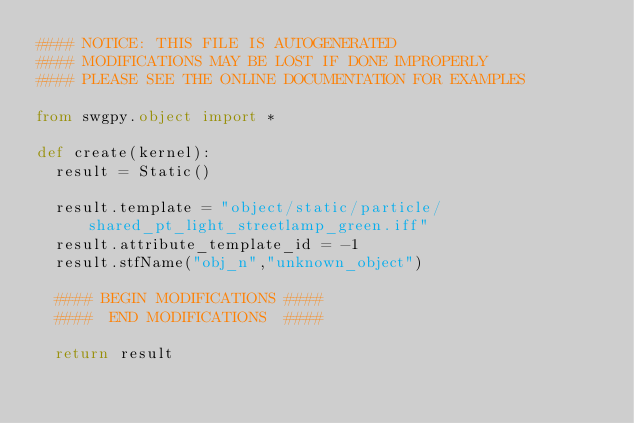<code> <loc_0><loc_0><loc_500><loc_500><_Python_>#### NOTICE: THIS FILE IS AUTOGENERATED
#### MODIFICATIONS MAY BE LOST IF DONE IMPROPERLY
#### PLEASE SEE THE ONLINE DOCUMENTATION FOR EXAMPLES

from swgpy.object import *	

def create(kernel):
	result = Static()

	result.template = "object/static/particle/shared_pt_light_streetlamp_green.iff"
	result.attribute_template_id = -1
	result.stfName("obj_n","unknown_object")		
	
	#### BEGIN MODIFICATIONS ####
	####  END MODIFICATIONS  ####
	
	return result</code> 